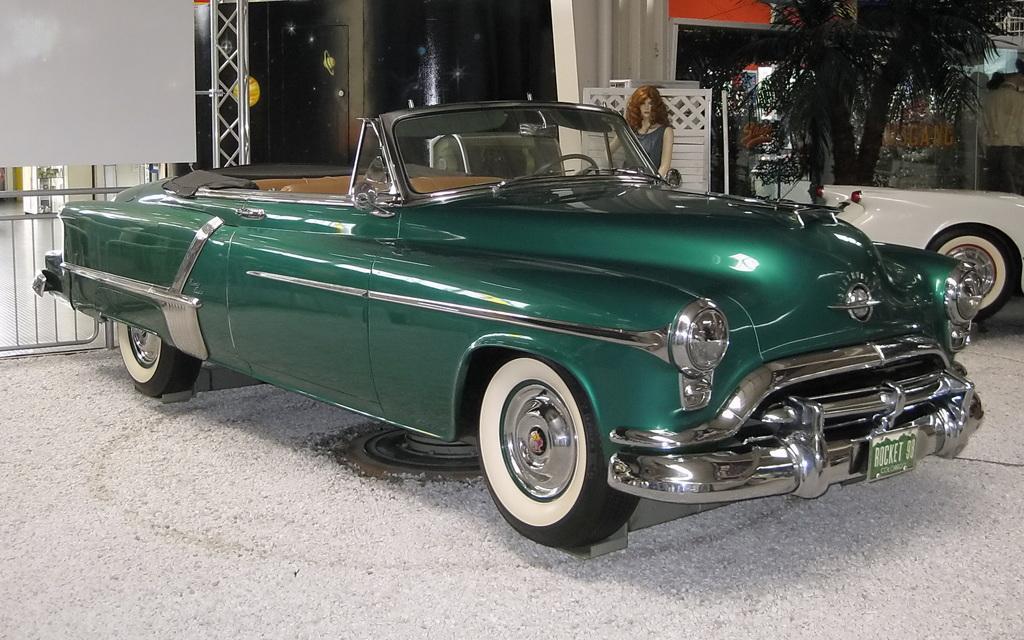Describe this image in one or two sentences. In the picture we can see a vintage car which is green in color parked on the path and beside we can see another car which is white in color and in the background we can see railing, stage and a mannequin and some trees behind it. 